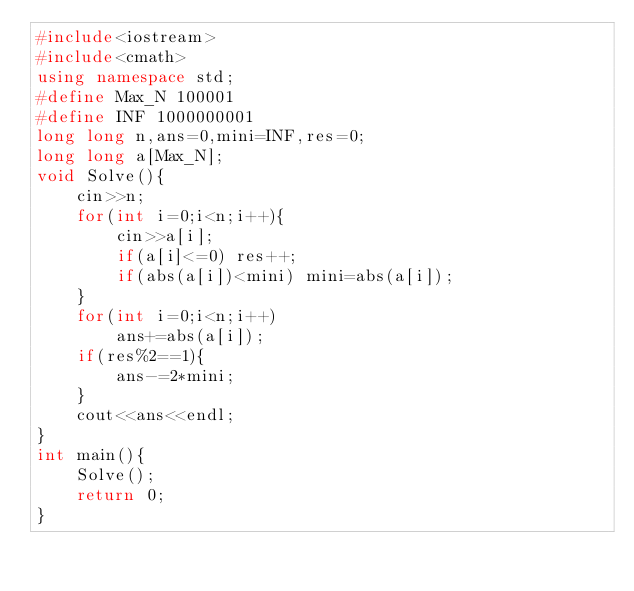<code> <loc_0><loc_0><loc_500><loc_500><_C++_>#include<iostream>
#include<cmath>
using namespace std;
#define Max_N 100001
#define INF 1000000001
long long n,ans=0,mini=INF,res=0;
long long a[Max_N];
void Solve(){
    cin>>n;
    for(int i=0;i<n;i++){
        cin>>a[i];
        if(a[i]<=0) res++;
        if(abs(a[i])<mini) mini=abs(a[i]);
    }
    for(int i=0;i<n;i++)
        ans+=abs(a[i]);
    if(res%2==1){
        ans-=2*mini;
    }
    cout<<ans<<endl;
}
int main(){
    Solve();
    return 0;
}</code> 